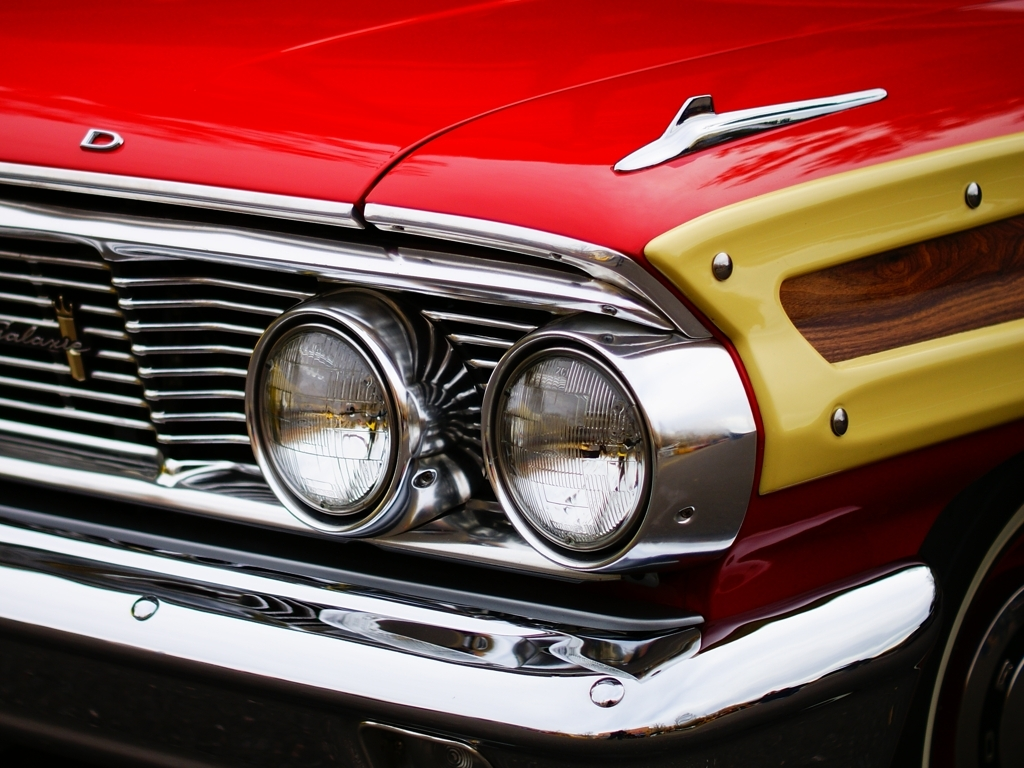What can you tell me about the craftsmanship? The craftsmanship on display here reveals a high level of attention to detail and quality that was characteristic of the era this car was built. Specifically, the precision of the chrome trim, the excellent fit and alignment of the body panels, and the wood panel insert all speak to the skilled workmanship that went into creating this automobile. 